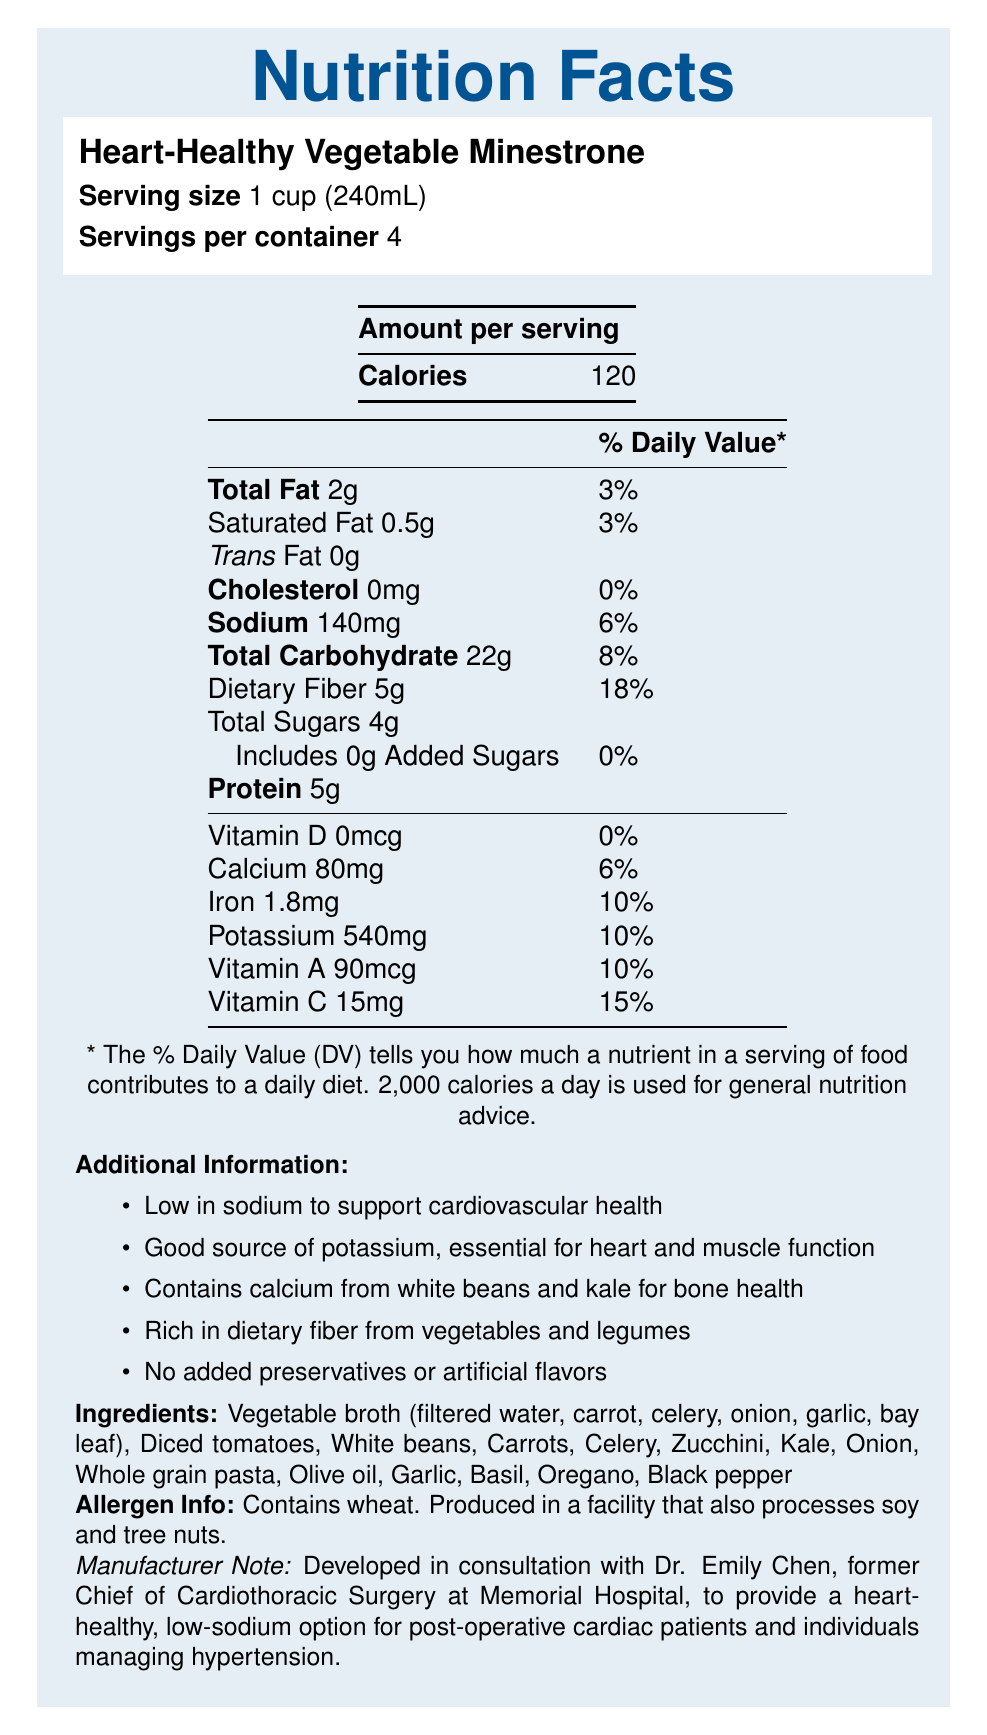What is the serving size for the Heart-Healthy Vegetable Minestrone? The document states that the serving size is 1 cup (240mL).
Answer: 1 cup (240mL) How many calories are in one serving of the soup? The "Amount per serving" section lists the calorie content as 120.
Answer: 120 How much potassium is in one serving and what percentage of the daily value does it contribute? The Nutrition Facts section lists the amount of potassium per serving as 540 mg, which contributes to 10% of the daily value.
Answer: 540mg, 10% What is the total amount of dietary fiber in one serving of the soup? The document indicates that one serving contains 5 grams of dietary fiber.
Answer: 5g What are two sources of calcium mentioned in the document? The Additional Information section states that the soup contains calcium from white beans and kale.
Answer: White beans and kale Which of the following ingredients is not listed as part of the soup's components? A. Olive oil, B. Broccoli, C. Diced tomatoes, D. Garlic The Ingredients section does not list broccoli but includes olive oil, diced tomatoes, and garlic.
Answer: B. Broccoli What percentage of the daily value for vitamin C does one serving of this soup provide? A. 6%, B. 15%, C. 18%, D. 10% One serving of the soup provides 15% of the daily value for vitamin C.
Answer: B. 15% True or False: The soup contains added sugars. The document explicitly states that the soup includes 0g of added sugars.
Answer: False Summarize the main purposes and features of this nutrition document. The document primarily aims to inform consumers about the nutritional benefits and ingredients of the soup, focusing on heart health, bone strength, and natural ingredients.
Answer: The document provides a comprehensive breakdown of the nutritional content of Heart-Healthy Vegetable Minestrone soup, emphasizing its low sodium, high potassium, and calcium content, which support cardiovascular health and bone strength. It also highlights the soup’s high fiber content and the absence of added preservatives or artificial flavors. Additionally, it offers allergen information and mentions the collaboration with Dr. Emily Chen. How many servings are there in a container of Heart-Healthy Vegetable Minestrone? According to the document, there are 4 servings per container.
Answer: 4 What is the main cardiovascular benefit of consuming this soup? The Additional Information section states that the soup is low in sodium, which is beneficial for cardiovascular health.
Answer: Low in sodium to support cardiovascular health. Is the soup suitable for individuals managing hypertension? The document mentions that the soup is developed to provide a heart-healthy, low-sodium option for such individuals.
Answer: Yes What is the exact amount of calcium in one serving of the soup? The Nutrition Facts section lists the calcium content as 80mg per serving.
Answer: 80mg Does the document specify the total amount of protein in one serving of the soup? The document indicates that one serving contains 5 grams of protein.
Answer: Yes, 5g Who collaborated with the manufacturer to develop this soup? The Manufacturer Note section states that Dr. Emily Chen collaborated on the development of the soup.
Answer: Dr. Emily Chen, former Chief of Cardiothoracic Surgery at Memorial Hospital What is the cholesterol content per serving of the soup? The Nutrition Facts section lists the cholesterol content as 0mg per serving.
Answer: 0mg What is the sodium content in one serving of this soup and what percentage of the daily value does it represent? According to the document, one serving contains 140mg of sodium, which is 6% of the daily value.
Answer: 140mg, 6% Can you tell how much of the soup's sodium comes from added preservatives? The document states there are no added preservatives but does not specify how the sodium content is distributed.
Answer: Not enough information Which vitamin has the highest daily value percentage in one serving of the soup? The Nutrition Facts section shows that vitamin C has the highest daily value percentage at 15%.
Answer: Vitamin C, 15% 